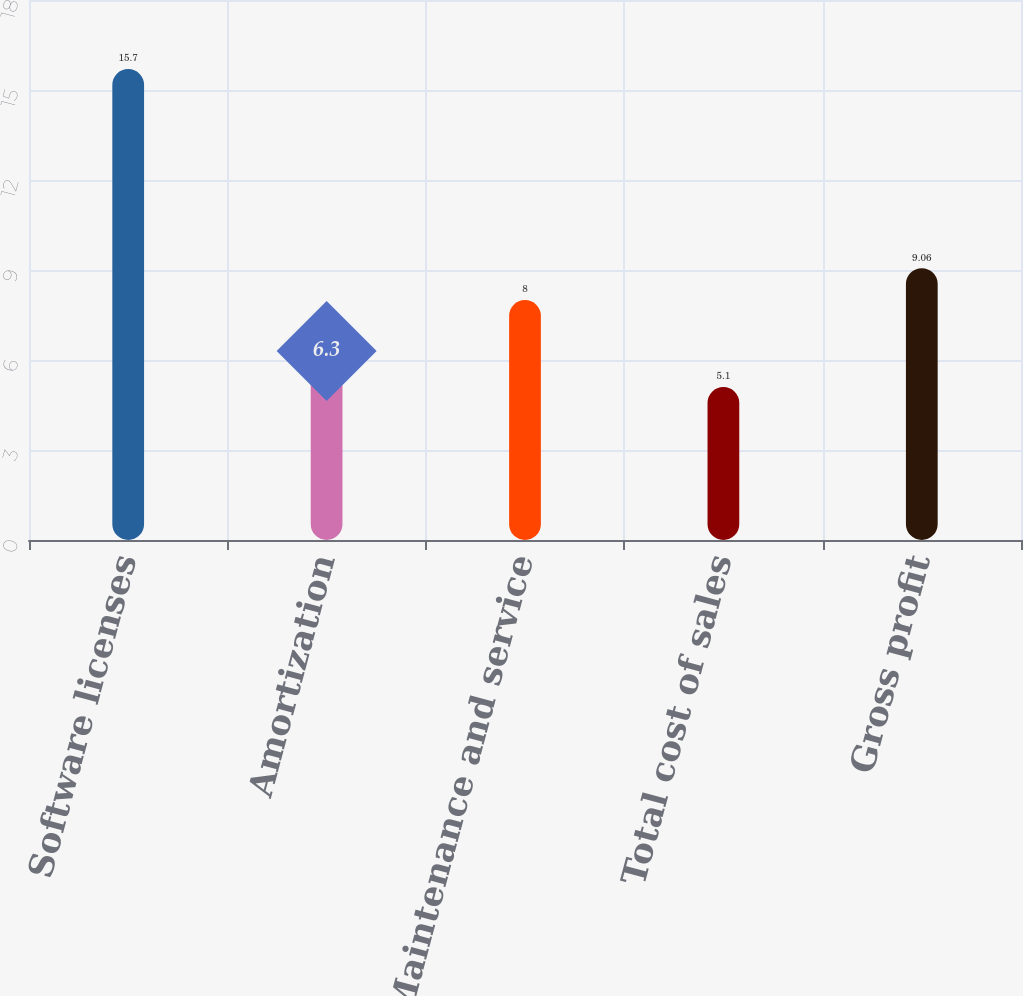Convert chart. <chart><loc_0><loc_0><loc_500><loc_500><bar_chart><fcel>Software licenses<fcel>Amortization<fcel>Maintenance and service<fcel>Total cost of sales<fcel>Gross profit<nl><fcel>15.7<fcel>6.3<fcel>8<fcel>5.1<fcel>9.06<nl></chart> 